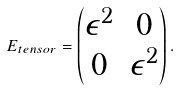Convert formula to latex. <formula><loc_0><loc_0><loc_500><loc_500>E _ { t e n s o r } = \begin{pmatrix} \epsilon ^ { 2 } & 0 \\ 0 & \epsilon ^ { 2 } \end{pmatrix} .</formula> 